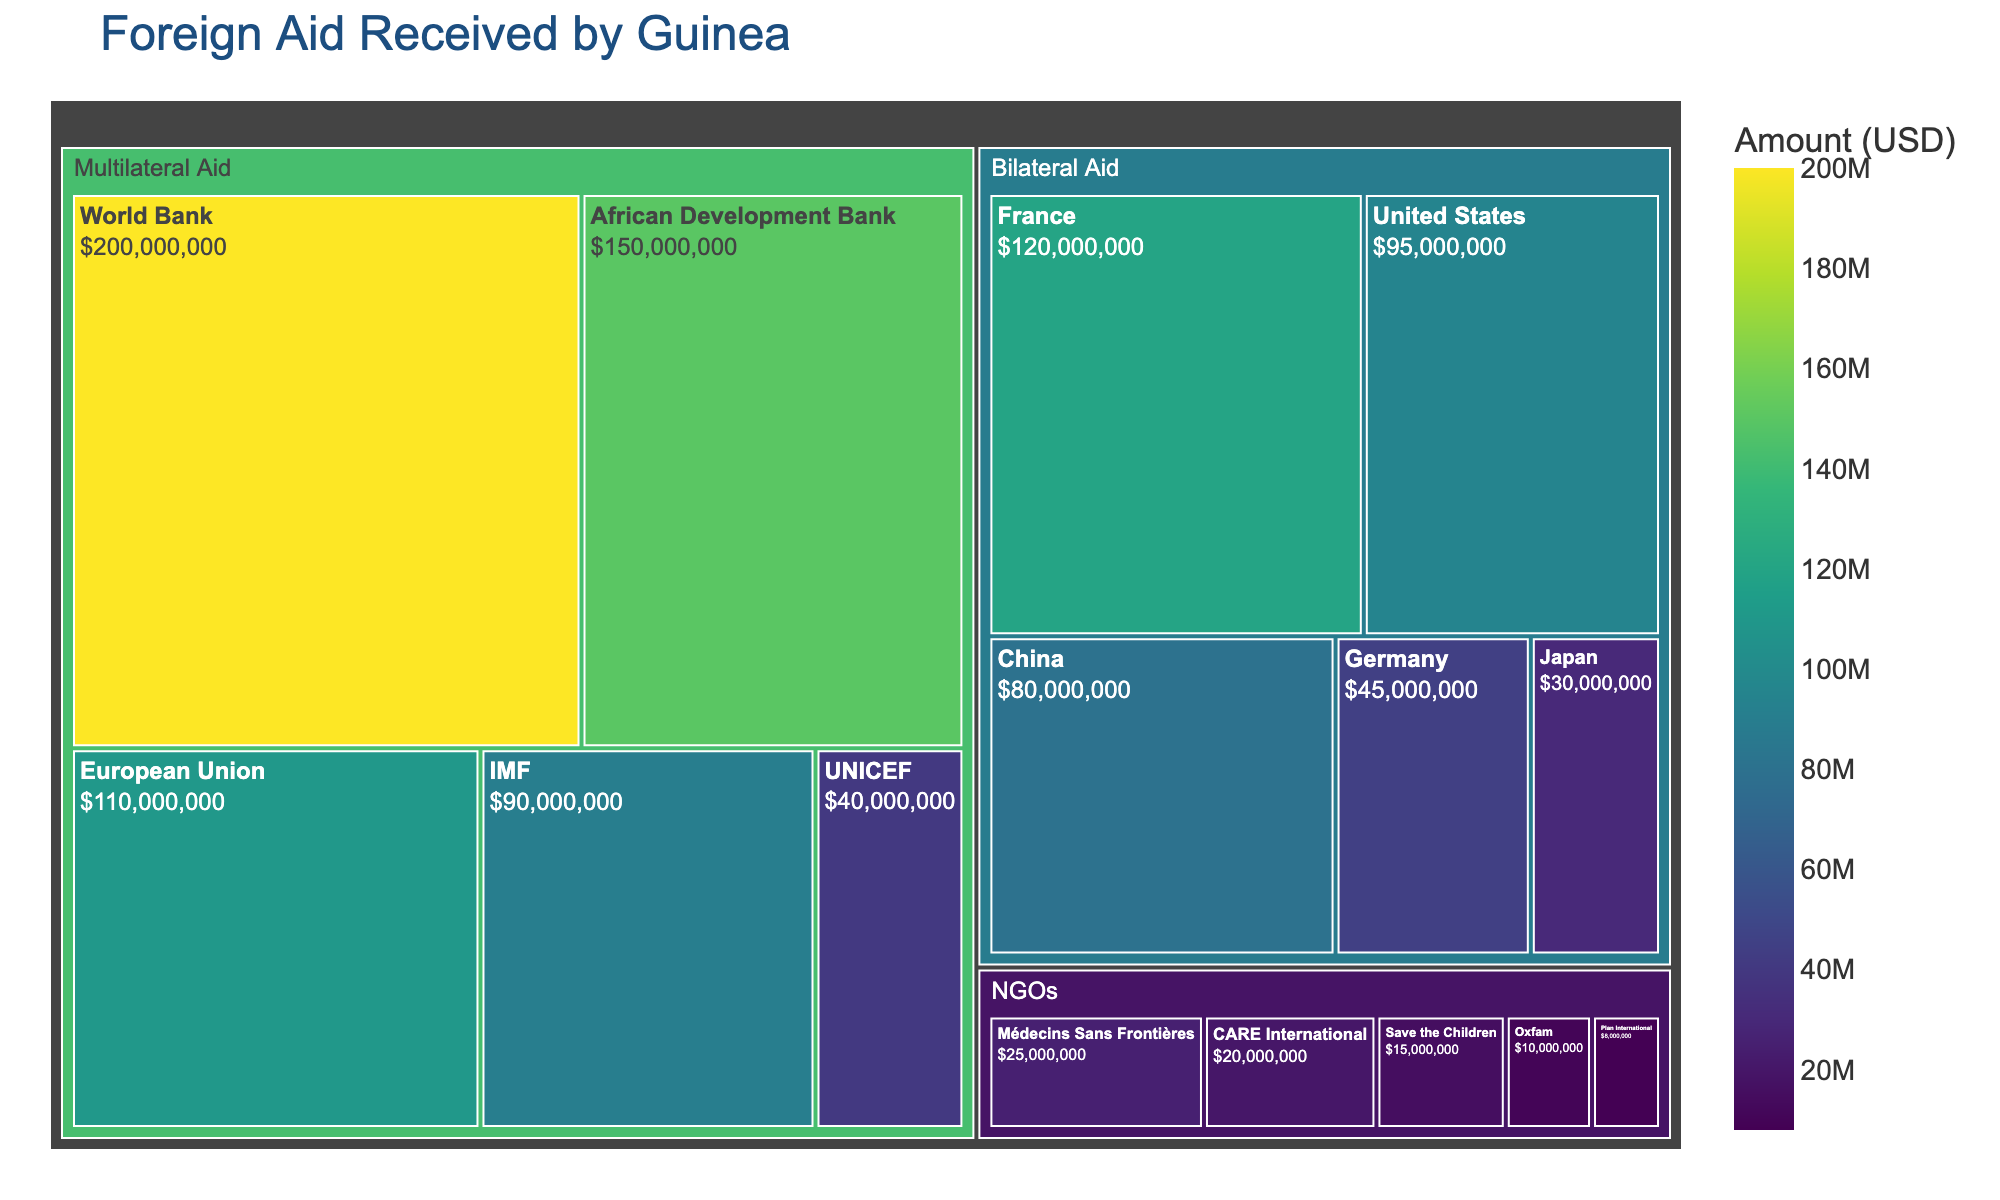What is the title of the treemap? The title usually appears at the top of the figure, summarizing the content it represents.
Answer: Foreign Aid Received by Guinea Which category received the highest total amount of aid? To find this, look at the largest segment in the treemap by evaluating the area.
Answer: Multilateral Aid Which donor provided the highest amount of aid? To answer, identify the rectangle with the largest area or the one with the highest value displayed in the treemap.
Answer: World Bank How much aid did France provide to Guinea? Check the amount listed within or next to the France segment of the treemap.
Answer: $120,000,000 Compare the aid received from France and Japan. Which is greater and by how much? Identify the amounts for France and Japan and then subtract the lesser amount from the greater amount.
Answer: France provided $90,000,000 more than Japan What is the combined total aid from NGOs? Sum the amounts from all segments under the NGO category.
Answer: $78,000,000 Which donor in the "Multilateral Aid" category provided more aid than the IMF? Compare individual amounts within the "Multilateral Aid" category to the amount provided by the IMF.
Answer: World Bank, African Development Bank, and European Union What percentage of the total aid comes from the World Bank? First, sum all aid amounts. Then, divide the World Bank's amount by this total and multiply by 100 to find the percentage.
Answer: Approximately 23.4% Is the aid from the African Development Bank greater than the combined aid from UNICEF and Oxfam? Add the amounts from UNICEF and Oxfam and compare the result with the amount provided by the African Development Bank.
Answer: Yes, the African Development Bank provided more 